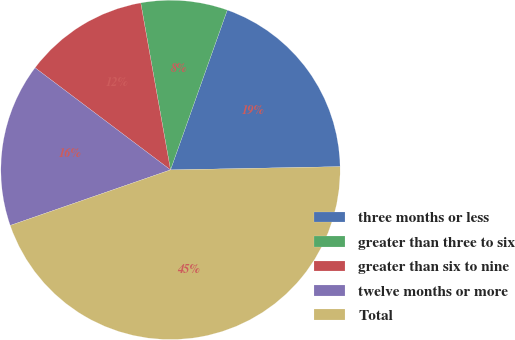Convert chart. <chart><loc_0><loc_0><loc_500><loc_500><pie_chart><fcel>three months or less<fcel>greater than three to six<fcel>greater than six to nine<fcel>twelve months or more<fcel>Total<nl><fcel>19.26%<fcel>8.24%<fcel>11.91%<fcel>15.59%<fcel>44.99%<nl></chart> 